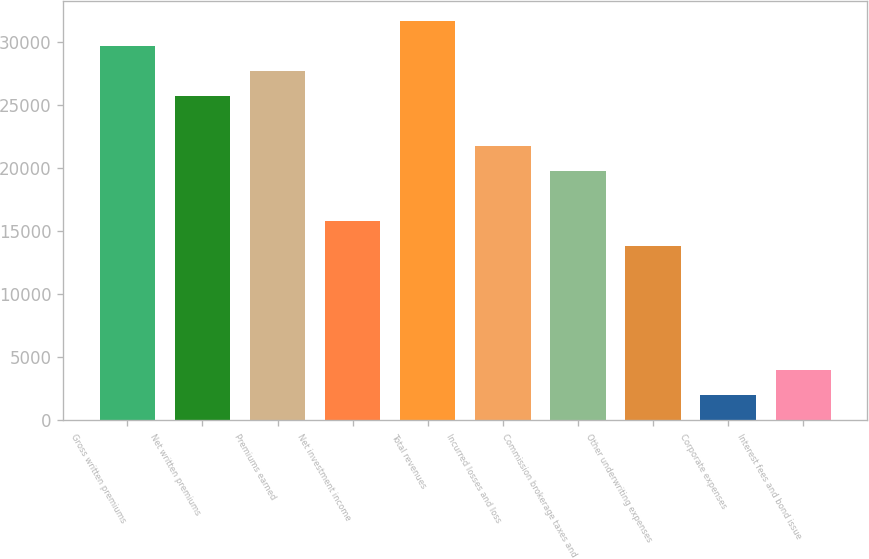Convert chart. <chart><loc_0><loc_0><loc_500><loc_500><bar_chart><fcel>Gross written premiums<fcel>Net written premiums<fcel>Premiums earned<fcel>Net investment income<fcel>Total revenues<fcel>Incurred losses and loss<fcel>Commission brokerage taxes and<fcel>Other underwriting expenses<fcel>Corporate expenses<fcel>Interest fees and bond issue<nl><fcel>29655.4<fcel>25704.4<fcel>27679.9<fcel>15826.9<fcel>31630.9<fcel>21753.4<fcel>19777.9<fcel>13851.4<fcel>1998.4<fcel>3973.9<nl></chart> 